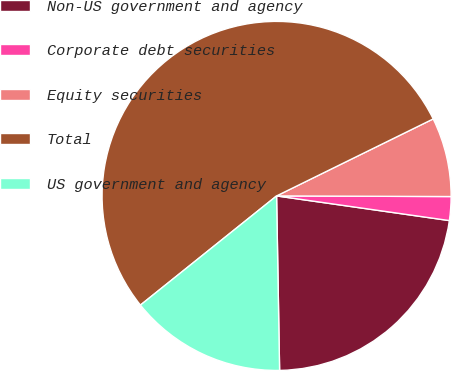Convert chart. <chart><loc_0><loc_0><loc_500><loc_500><pie_chart><fcel>Non-US government and agency<fcel>Corporate debt securities<fcel>Equity securities<fcel>Total<fcel>US government and agency<nl><fcel>22.47%<fcel>2.2%<fcel>7.33%<fcel>53.49%<fcel>14.52%<nl></chart> 